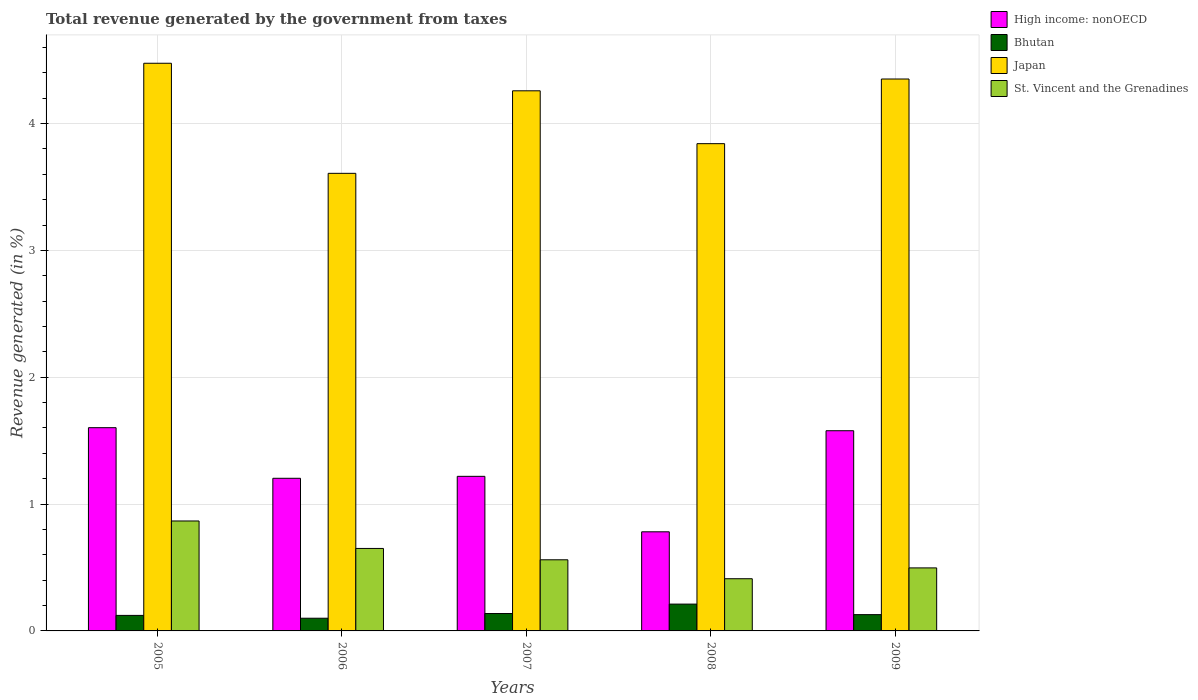How many different coloured bars are there?
Keep it short and to the point. 4. Are the number of bars on each tick of the X-axis equal?
Offer a very short reply. Yes. What is the label of the 3rd group of bars from the left?
Offer a very short reply. 2007. In how many cases, is the number of bars for a given year not equal to the number of legend labels?
Your response must be concise. 0. What is the total revenue generated in High income: nonOECD in 2007?
Ensure brevity in your answer.  1.22. Across all years, what is the maximum total revenue generated in High income: nonOECD?
Make the answer very short. 1.6. Across all years, what is the minimum total revenue generated in St. Vincent and the Grenadines?
Keep it short and to the point. 0.41. In which year was the total revenue generated in St. Vincent and the Grenadines minimum?
Offer a terse response. 2008. What is the total total revenue generated in High income: nonOECD in the graph?
Provide a short and direct response. 6.38. What is the difference between the total revenue generated in Japan in 2005 and that in 2007?
Provide a succinct answer. 0.22. What is the difference between the total revenue generated in Bhutan in 2005 and the total revenue generated in Japan in 2009?
Your answer should be very brief. -4.23. What is the average total revenue generated in St. Vincent and the Grenadines per year?
Provide a succinct answer. 0.6. In the year 2005, what is the difference between the total revenue generated in Japan and total revenue generated in St. Vincent and the Grenadines?
Ensure brevity in your answer.  3.61. What is the ratio of the total revenue generated in St. Vincent and the Grenadines in 2006 to that in 2007?
Make the answer very short. 1.16. Is the total revenue generated in Bhutan in 2007 less than that in 2009?
Make the answer very short. No. Is the difference between the total revenue generated in Japan in 2005 and 2008 greater than the difference between the total revenue generated in St. Vincent and the Grenadines in 2005 and 2008?
Offer a terse response. Yes. What is the difference between the highest and the second highest total revenue generated in Bhutan?
Your answer should be compact. 0.07. What is the difference between the highest and the lowest total revenue generated in High income: nonOECD?
Your response must be concise. 0.82. Is the sum of the total revenue generated in High income: nonOECD in 2005 and 2009 greater than the maximum total revenue generated in Japan across all years?
Keep it short and to the point. No. Is it the case that in every year, the sum of the total revenue generated in Bhutan and total revenue generated in Japan is greater than the sum of total revenue generated in St. Vincent and the Grenadines and total revenue generated in High income: nonOECD?
Provide a succinct answer. Yes. What does the 1st bar from the left in 2007 represents?
Give a very brief answer. High income: nonOECD. What does the 1st bar from the right in 2005 represents?
Your answer should be compact. St. Vincent and the Grenadines. Is it the case that in every year, the sum of the total revenue generated in Japan and total revenue generated in High income: nonOECD is greater than the total revenue generated in St. Vincent and the Grenadines?
Offer a very short reply. Yes. Are all the bars in the graph horizontal?
Your answer should be very brief. No. How many years are there in the graph?
Offer a very short reply. 5. What is the difference between two consecutive major ticks on the Y-axis?
Your answer should be compact. 1. Are the values on the major ticks of Y-axis written in scientific E-notation?
Offer a terse response. No. Does the graph contain any zero values?
Provide a short and direct response. No. Does the graph contain grids?
Your response must be concise. Yes. Where does the legend appear in the graph?
Provide a short and direct response. Top right. How many legend labels are there?
Keep it short and to the point. 4. What is the title of the graph?
Ensure brevity in your answer.  Total revenue generated by the government from taxes. What is the label or title of the Y-axis?
Ensure brevity in your answer.  Revenue generated (in %). What is the Revenue generated (in %) of High income: nonOECD in 2005?
Your answer should be compact. 1.6. What is the Revenue generated (in %) in Bhutan in 2005?
Keep it short and to the point. 0.12. What is the Revenue generated (in %) in Japan in 2005?
Provide a short and direct response. 4.48. What is the Revenue generated (in %) in St. Vincent and the Grenadines in 2005?
Provide a succinct answer. 0.87. What is the Revenue generated (in %) in High income: nonOECD in 2006?
Make the answer very short. 1.2. What is the Revenue generated (in %) of Bhutan in 2006?
Provide a short and direct response. 0.1. What is the Revenue generated (in %) in Japan in 2006?
Offer a terse response. 3.61. What is the Revenue generated (in %) in St. Vincent and the Grenadines in 2006?
Make the answer very short. 0.65. What is the Revenue generated (in %) of High income: nonOECD in 2007?
Ensure brevity in your answer.  1.22. What is the Revenue generated (in %) of Bhutan in 2007?
Provide a short and direct response. 0.14. What is the Revenue generated (in %) in Japan in 2007?
Offer a very short reply. 4.26. What is the Revenue generated (in %) in St. Vincent and the Grenadines in 2007?
Ensure brevity in your answer.  0.56. What is the Revenue generated (in %) in High income: nonOECD in 2008?
Ensure brevity in your answer.  0.78. What is the Revenue generated (in %) in Bhutan in 2008?
Make the answer very short. 0.21. What is the Revenue generated (in %) of Japan in 2008?
Your answer should be very brief. 3.84. What is the Revenue generated (in %) in St. Vincent and the Grenadines in 2008?
Your answer should be very brief. 0.41. What is the Revenue generated (in %) in High income: nonOECD in 2009?
Offer a very short reply. 1.58. What is the Revenue generated (in %) in Bhutan in 2009?
Give a very brief answer. 0.13. What is the Revenue generated (in %) of Japan in 2009?
Offer a terse response. 4.35. What is the Revenue generated (in %) of St. Vincent and the Grenadines in 2009?
Provide a short and direct response. 0.5. Across all years, what is the maximum Revenue generated (in %) in High income: nonOECD?
Ensure brevity in your answer.  1.6. Across all years, what is the maximum Revenue generated (in %) in Bhutan?
Your answer should be compact. 0.21. Across all years, what is the maximum Revenue generated (in %) of Japan?
Your response must be concise. 4.48. Across all years, what is the maximum Revenue generated (in %) of St. Vincent and the Grenadines?
Your answer should be compact. 0.87. Across all years, what is the minimum Revenue generated (in %) in High income: nonOECD?
Make the answer very short. 0.78. Across all years, what is the minimum Revenue generated (in %) of Bhutan?
Provide a short and direct response. 0.1. Across all years, what is the minimum Revenue generated (in %) in Japan?
Ensure brevity in your answer.  3.61. Across all years, what is the minimum Revenue generated (in %) in St. Vincent and the Grenadines?
Your answer should be compact. 0.41. What is the total Revenue generated (in %) in High income: nonOECD in the graph?
Your answer should be compact. 6.38. What is the total Revenue generated (in %) in Bhutan in the graph?
Make the answer very short. 0.7. What is the total Revenue generated (in %) of Japan in the graph?
Provide a short and direct response. 20.53. What is the total Revenue generated (in %) of St. Vincent and the Grenadines in the graph?
Make the answer very short. 2.99. What is the difference between the Revenue generated (in %) in High income: nonOECD in 2005 and that in 2006?
Provide a short and direct response. 0.4. What is the difference between the Revenue generated (in %) of Bhutan in 2005 and that in 2006?
Offer a very short reply. 0.02. What is the difference between the Revenue generated (in %) of Japan in 2005 and that in 2006?
Provide a succinct answer. 0.87. What is the difference between the Revenue generated (in %) of St. Vincent and the Grenadines in 2005 and that in 2006?
Provide a succinct answer. 0.22. What is the difference between the Revenue generated (in %) of High income: nonOECD in 2005 and that in 2007?
Offer a terse response. 0.38. What is the difference between the Revenue generated (in %) in Bhutan in 2005 and that in 2007?
Offer a very short reply. -0.01. What is the difference between the Revenue generated (in %) of Japan in 2005 and that in 2007?
Give a very brief answer. 0.22. What is the difference between the Revenue generated (in %) of St. Vincent and the Grenadines in 2005 and that in 2007?
Your response must be concise. 0.31. What is the difference between the Revenue generated (in %) in High income: nonOECD in 2005 and that in 2008?
Give a very brief answer. 0.82. What is the difference between the Revenue generated (in %) in Bhutan in 2005 and that in 2008?
Keep it short and to the point. -0.09. What is the difference between the Revenue generated (in %) of Japan in 2005 and that in 2008?
Provide a short and direct response. 0.63. What is the difference between the Revenue generated (in %) in St. Vincent and the Grenadines in 2005 and that in 2008?
Your response must be concise. 0.46. What is the difference between the Revenue generated (in %) of High income: nonOECD in 2005 and that in 2009?
Provide a short and direct response. 0.02. What is the difference between the Revenue generated (in %) in Bhutan in 2005 and that in 2009?
Your answer should be compact. -0.01. What is the difference between the Revenue generated (in %) in Japan in 2005 and that in 2009?
Offer a very short reply. 0.12. What is the difference between the Revenue generated (in %) of St. Vincent and the Grenadines in 2005 and that in 2009?
Keep it short and to the point. 0.37. What is the difference between the Revenue generated (in %) in High income: nonOECD in 2006 and that in 2007?
Provide a short and direct response. -0.02. What is the difference between the Revenue generated (in %) of Bhutan in 2006 and that in 2007?
Offer a very short reply. -0.04. What is the difference between the Revenue generated (in %) in Japan in 2006 and that in 2007?
Your answer should be very brief. -0.65. What is the difference between the Revenue generated (in %) in St. Vincent and the Grenadines in 2006 and that in 2007?
Provide a short and direct response. 0.09. What is the difference between the Revenue generated (in %) in High income: nonOECD in 2006 and that in 2008?
Offer a terse response. 0.42. What is the difference between the Revenue generated (in %) of Bhutan in 2006 and that in 2008?
Ensure brevity in your answer.  -0.11. What is the difference between the Revenue generated (in %) in Japan in 2006 and that in 2008?
Give a very brief answer. -0.23. What is the difference between the Revenue generated (in %) of St. Vincent and the Grenadines in 2006 and that in 2008?
Keep it short and to the point. 0.24. What is the difference between the Revenue generated (in %) of High income: nonOECD in 2006 and that in 2009?
Provide a short and direct response. -0.38. What is the difference between the Revenue generated (in %) of Bhutan in 2006 and that in 2009?
Ensure brevity in your answer.  -0.03. What is the difference between the Revenue generated (in %) in Japan in 2006 and that in 2009?
Offer a terse response. -0.74. What is the difference between the Revenue generated (in %) in St. Vincent and the Grenadines in 2006 and that in 2009?
Give a very brief answer. 0.15. What is the difference between the Revenue generated (in %) in High income: nonOECD in 2007 and that in 2008?
Keep it short and to the point. 0.44. What is the difference between the Revenue generated (in %) in Bhutan in 2007 and that in 2008?
Give a very brief answer. -0.07. What is the difference between the Revenue generated (in %) in Japan in 2007 and that in 2008?
Make the answer very short. 0.42. What is the difference between the Revenue generated (in %) in St. Vincent and the Grenadines in 2007 and that in 2008?
Ensure brevity in your answer.  0.15. What is the difference between the Revenue generated (in %) in High income: nonOECD in 2007 and that in 2009?
Make the answer very short. -0.36. What is the difference between the Revenue generated (in %) of Bhutan in 2007 and that in 2009?
Your answer should be very brief. 0.01. What is the difference between the Revenue generated (in %) of Japan in 2007 and that in 2009?
Your response must be concise. -0.09. What is the difference between the Revenue generated (in %) of St. Vincent and the Grenadines in 2007 and that in 2009?
Provide a short and direct response. 0.06. What is the difference between the Revenue generated (in %) in High income: nonOECD in 2008 and that in 2009?
Offer a terse response. -0.8. What is the difference between the Revenue generated (in %) of Bhutan in 2008 and that in 2009?
Give a very brief answer. 0.08. What is the difference between the Revenue generated (in %) in Japan in 2008 and that in 2009?
Ensure brevity in your answer.  -0.51. What is the difference between the Revenue generated (in %) in St. Vincent and the Grenadines in 2008 and that in 2009?
Your answer should be compact. -0.09. What is the difference between the Revenue generated (in %) of High income: nonOECD in 2005 and the Revenue generated (in %) of Bhutan in 2006?
Provide a succinct answer. 1.5. What is the difference between the Revenue generated (in %) of High income: nonOECD in 2005 and the Revenue generated (in %) of Japan in 2006?
Keep it short and to the point. -2.01. What is the difference between the Revenue generated (in %) in High income: nonOECD in 2005 and the Revenue generated (in %) in St. Vincent and the Grenadines in 2006?
Offer a terse response. 0.95. What is the difference between the Revenue generated (in %) of Bhutan in 2005 and the Revenue generated (in %) of Japan in 2006?
Provide a succinct answer. -3.48. What is the difference between the Revenue generated (in %) of Bhutan in 2005 and the Revenue generated (in %) of St. Vincent and the Grenadines in 2006?
Offer a terse response. -0.53. What is the difference between the Revenue generated (in %) in Japan in 2005 and the Revenue generated (in %) in St. Vincent and the Grenadines in 2006?
Your response must be concise. 3.83. What is the difference between the Revenue generated (in %) in High income: nonOECD in 2005 and the Revenue generated (in %) in Bhutan in 2007?
Provide a short and direct response. 1.47. What is the difference between the Revenue generated (in %) of High income: nonOECD in 2005 and the Revenue generated (in %) of Japan in 2007?
Provide a succinct answer. -2.66. What is the difference between the Revenue generated (in %) of High income: nonOECD in 2005 and the Revenue generated (in %) of St. Vincent and the Grenadines in 2007?
Give a very brief answer. 1.04. What is the difference between the Revenue generated (in %) of Bhutan in 2005 and the Revenue generated (in %) of Japan in 2007?
Ensure brevity in your answer.  -4.14. What is the difference between the Revenue generated (in %) in Bhutan in 2005 and the Revenue generated (in %) in St. Vincent and the Grenadines in 2007?
Offer a terse response. -0.44. What is the difference between the Revenue generated (in %) of Japan in 2005 and the Revenue generated (in %) of St. Vincent and the Grenadines in 2007?
Ensure brevity in your answer.  3.91. What is the difference between the Revenue generated (in %) in High income: nonOECD in 2005 and the Revenue generated (in %) in Bhutan in 2008?
Your response must be concise. 1.39. What is the difference between the Revenue generated (in %) in High income: nonOECD in 2005 and the Revenue generated (in %) in Japan in 2008?
Make the answer very short. -2.24. What is the difference between the Revenue generated (in %) of High income: nonOECD in 2005 and the Revenue generated (in %) of St. Vincent and the Grenadines in 2008?
Your response must be concise. 1.19. What is the difference between the Revenue generated (in %) of Bhutan in 2005 and the Revenue generated (in %) of Japan in 2008?
Your answer should be very brief. -3.72. What is the difference between the Revenue generated (in %) in Bhutan in 2005 and the Revenue generated (in %) in St. Vincent and the Grenadines in 2008?
Offer a very short reply. -0.29. What is the difference between the Revenue generated (in %) of Japan in 2005 and the Revenue generated (in %) of St. Vincent and the Grenadines in 2008?
Your response must be concise. 4.06. What is the difference between the Revenue generated (in %) in High income: nonOECD in 2005 and the Revenue generated (in %) in Bhutan in 2009?
Your answer should be compact. 1.47. What is the difference between the Revenue generated (in %) of High income: nonOECD in 2005 and the Revenue generated (in %) of Japan in 2009?
Offer a very short reply. -2.75. What is the difference between the Revenue generated (in %) of High income: nonOECD in 2005 and the Revenue generated (in %) of St. Vincent and the Grenadines in 2009?
Your response must be concise. 1.11. What is the difference between the Revenue generated (in %) in Bhutan in 2005 and the Revenue generated (in %) in Japan in 2009?
Ensure brevity in your answer.  -4.23. What is the difference between the Revenue generated (in %) in Bhutan in 2005 and the Revenue generated (in %) in St. Vincent and the Grenadines in 2009?
Give a very brief answer. -0.37. What is the difference between the Revenue generated (in %) of Japan in 2005 and the Revenue generated (in %) of St. Vincent and the Grenadines in 2009?
Your answer should be very brief. 3.98. What is the difference between the Revenue generated (in %) in High income: nonOECD in 2006 and the Revenue generated (in %) in Bhutan in 2007?
Offer a terse response. 1.07. What is the difference between the Revenue generated (in %) in High income: nonOECD in 2006 and the Revenue generated (in %) in Japan in 2007?
Provide a succinct answer. -3.05. What is the difference between the Revenue generated (in %) of High income: nonOECD in 2006 and the Revenue generated (in %) of St. Vincent and the Grenadines in 2007?
Make the answer very short. 0.64. What is the difference between the Revenue generated (in %) of Bhutan in 2006 and the Revenue generated (in %) of Japan in 2007?
Offer a terse response. -4.16. What is the difference between the Revenue generated (in %) in Bhutan in 2006 and the Revenue generated (in %) in St. Vincent and the Grenadines in 2007?
Your answer should be compact. -0.46. What is the difference between the Revenue generated (in %) of Japan in 2006 and the Revenue generated (in %) of St. Vincent and the Grenadines in 2007?
Give a very brief answer. 3.05. What is the difference between the Revenue generated (in %) of High income: nonOECD in 2006 and the Revenue generated (in %) of Bhutan in 2008?
Keep it short and to the point. 0.99. What is the difference between the Revenue generated (in %) in High income: nonOECD in 2006 and the Revenue generated (in %) in Japan in 2008?
Your response must be concise. -2.64. What is the difference between the Revenue generated (in %) in High income: nonOECD in 2006 and the Revenue generated (in %) in St. Vincent and the Grenadines in 2008?
Offer a terse response. 0.79. What is the difference between the Revenue generated (in %) in Bhutan in 2006 and the Revenue generated (in %) in Japan in 2008?
Keep it short and to the point. -3.74. What is the difference between the Revenue generated (in %) of Bhutan in 2006 and the Revenue generated (in %) of St. Vincent and the Grenadines in 2008?
Provide a short and direct response. -0.31. What is the difference between the Revenue generated (in %) of Japan in 2006 and the Revenue generated (in %) of St. Vincent and the Grenadines in 2008?
Offer a very short reply. 3.2. What is the difference between the Revenue generated (in %) in High income: nonOECD in 2006 and the Revenue generated (in %) in Bhutan in 2009?
Offer a very short reply. 1.07. What is the difference between the Revenue generated (in %) of High income: nonOECD in 2006 and the Revenue generated (in %) of Japan in 2009?
Make the answer very short. -3.15. What is the difference between the Revenue generated (in %) of High income: nonOECD in 2006 and the Revenue generated (in %) of St. Vincent and the Grenadines in 2009?
Your answer should be very brief. 0.71. What is the difference between the Revenue generated (in %) of Bhutan in 2006 and the Revenue generated (in %) of Japan in 2009?
Keep it short and to the point. -4.25. What is the difference between the Revenue generated (in %) of Bhutan in 2006 and the Revenue generated (in %) of St. Vincent and the Grenadines in 2009?
Offer a very short reply. -0.4. What is the difference between the Revenue generated (in %) in Japan in 2006 and the Revenue generated (in %) in St. Vincent and the Grenadines in 2009?
Give a very brief answer. 3.11. What is the difference between the Revenue generated (in %) in High income: nonOECD in 2007 and the Revenue generated (in %) in Bhutan in 2008?
Offer a very short reply. 1.01. What is the difference between the Revenue generated (in %) in High income: nonOECD in 2007 and the Revenue generated (in %) in Japan in 2008?
Your answer should be very brief. -2.62. What is the difference between the Revenue generated (in %) of High income: nonOECD in 2007 and the Revenue generated (in %) of St. Vincent and the Grenadines in 2008?
Make the answer very short. 0.81. What is the difference between the Revenue generated (in %) of Bhutan in 2007 and the Revenue generated (in %) of Japan in 2008?
Make the answer very short. -3.7. What is the difference between the Revenue generated (in %) in Bhutan in 2007 and the Revenue generated (in %) in St. Vincent and the Grenadines in 2008?
Provide a short and direct response. -0.27. What is the difference between the Revenue generated (in %) of Japan in 2007 and the Revenue generated (in %) of St. Vincent and the Grenadines in 2008?
Keep it short and to the point. 3.85. What is the difference between the Revenue generated (in %) of High income: nonOECD in 2007 and the Revenue generated (in %) of Bhutan in 2009?
Your answer should be very brief. 1.09. What is the difference between the Revenue generated (in %) in High income: nonOECD in 2007 and the Revenue generated (in %) in Japan in 2009?
Make the answer very short. -3.13. What is the difference between the Revenue generated (in %) of High income: nonOECD in 2007 and the Revenue generated (in %) of St. Vincent and the Grenadines in 2009?
Give a very brief answer. 0.72. What is the difference between the Revenue generated (in %) in Bhutan in 2007 and the Revenue generated (in %) in Japan in 2009?
Keep it short and to the point. -4.21. What is the difference between the Revenue generated (in %) in Bhutan in 2007 and the Revenue generated (in %) in St. Vincent and the Grenadines in 2009?
Offer a very short reply. -0.36. What is the difference between the Revenue generated (in %) of Japan in 2007 and the Revenue generated (in %) of St. Vincent and the Grenadines in 2009?
Offer a very short reply. 3.76. What is the difference between the Revenue generated (in %) of High income: nonOECD in 2008 and the Revenue generated (in %) of Bhutan in 2009?
Provide a succinct answer. 0.65. What is the difference between the Revenue generated (in %) in High income: nonOECD in 2008 and the Revenue generated (in %) in Japan in 2009?
Provide a succinct answer. -3.57. What is the difference between the Revenue generated (in %) in High income: nonOECD in 2008 and the Revenue generated (in %) in St. Vincent and the Grenadines in 2009?
Your answer should be compact. 0.28. What is the difference between the Revenue generated (in %) of Bhutan in 2008 and the Revenue generated (in %) of Japan in 2009?
Give a very brief answer. -4.14. What is the difference between the Revenue generated (in %) of Bhutan in 2008 and the Revenue generated (in %) of St. Vincent and the Grenadines in 2009?
Give a very brief answer. -0.29. What is the difference between the Revenue generated (in %) of Japan in 2008 and the Revenue generated (in %) of St. Vincent and the Grenadines in 2009?
Your answer should be very brief. 3.34. What is the average Revenue generated (in %) of High income: nonOECD per year?
Provide a succinct answer. 1.28. What is the average Revenue generated (in %) of Bhutan per year?
Offer a very short reply. 0.14. What is the average Revenue generated (in %) in Japan per year?
Your response must be concise. 4.11. What is the average Revenue generated (in %) of St. Vincent and the Grenadines per year?
Ensure brevity in your answer.  0.6. In the year 2005, what is the difference between the Revenue generated (in %) of High income: nonOECD and Revenue generated (in %) of Bhutan?
Your answer should be very brief. 1.48. In the year 2005, what is the difference between the Revenue generated (in %) of High income: nonOECD and Revenue generated (in %) of Japan?
Offer a very short reply. -2.87. In the year 2005, what is the difference between the Revenue generated (in %) in High income: nonOECD and Revenue generated (in %) in St. Vincent and the Grenadines?
Give a very brief answer. 0.74. In the year 2005, what is the difference between the Revenue generated (in %) of Bhutan and Revenue generated (in %) of Japan?
Your response must be concise. -4.35. In the year 2005, what is the difference between the Revenue generated (in %) in Bhutan and Revenue generated (in %) in St. Vincent and the Grenadines?
Keep it short and to the point. -0.74. In the year 2005, what is the difference between the Revenue generated (in %) in Japan and Revenue generated (in %) in St. Vincent and the Grenadines?
Make the answer very short. 3.61. In the year 2006, what is the difference between the Revenue generated (in %) in High income: nonOECD and Revenue generated (in %) in Bhutan?
Your response must be concise. 1.1. In the year 2006, what is the difference between the Revenue generated (in %) in High income: nonOECD and Revenue generated (in %) in Japan?
Keep it short and to the point. -2.4. In the year 2006, what is the difference between the Revenue generated (in %) of High income: nonOECD and Revenue generated (in %) of St. Vincent and the Grenadines?
Give a very brief answer. 0.55. In the year 2006, what is the difference between the Revenue generated (in %) of Bhutan and Revenue generated (in %) of Japan?
Your answer should be very brief. -3.51. In the year 2006, what is the difference between the Revenue generated (in %) of Bhutan and Revenue generated (in %) of St. Vincent and the Grenadines?
Provide a succinct answer. -0.55. In the year 2006, what is the difference between the Revenue generated (in %) in Japan and Revenue generated (in %) in St. Vincent and the Grenadines?
Ensure brevity in your answer.  2.96. In the year 2007, what is the difference between the Revenue generated (in %) of High income: nonOECD and Revenue generated (in %) of Bhutan?
Keep it short and to the point. 1.08. In the year 2007, what is the difference between the Revenue generated (in %) of High income: nonOECD and Revenue generated (in %) of Japan?
Make the answer very short. -3.04. In the year 2007, what is the difference between the Revenue generated (in %) in High income: nonOECD and Revenue generated (in %) in St. Vincent and the Grenadines?
Your response must be concise. 0.66. In the year 2007, what is the difference between the Revenue generated (in %) in Bhutan and Revenue generated (in %) in Japan?
Keep it short and to the point. -4.12. In the year 2007, what is the difference between the Revenue generated (in %) in Bhutan and Revenue generated (in %) in St. Vincent and the Grenadines?
Your answer should be compact. -0.42. In the year 2007, what is the difference between the Revenue generated (in %) in Japan and Revenue generated (in %) in St. Vincent and the Grenadines?
Provide a short and direct response. 3.7. In the year 2008, what is the difference between the Revenue generated (in %) of High income: nonOECD and Revenue generated (in %) of Bhutan?
Offer a very short reply. 0.57. In the year 2008, what is the difference between the Revenue generated (in %) in High income: nonOECD and Revenue generated (in %) in Japan?
Make the answer very short. -3.06. In the year 2008, what is the difference between the Revenue generated (in %) of High income: nonOECD and Revenue generated (in %) of St. Vincent and the Grenadines?
Give a very brief answer. 0.37. In the year 2008, what is the difference between the Revenue generated (in %) in Bhutan and Revenue generated (in %) in Japan?
Keep it short and to the point. -3.63. In the year 2008, what is the difference between the Revenue generated (in %) in Bhutan and Revenue generated (in %) in St. Vincent and the Grenadines?
Give a very brief answer. -0.2. In the year 2008, what is the difference between the Revenue generated (in %) in Japan and Revenue generated (in %) in St. Vincent and the Grenadines?
Your response must be concise. 3.43. In the year 2009, what is the difference between the Revenue generated (in %) of High income: nonOECD and Revenue generated (in %) of Bhutan?
Give a very brief answer. 1.45. In the year 2009, what is the difference between the Revenue generated (in %) of High income: nonOECD and Revenue generated (in %) of Japan?
Give a very brief answer. -2.77. In the year 2009, what is the difference between the Revenue generated (in %) of High income: nonOECD and Revenue generated (in %) of St. Vincent and the Grenadines?
Your answer should be compact. 1.08. In the year 2009, what is the difference between the Revenue generated (in %) in Bhutan and Revenue generated (in %) in Japan?
Give a very brief answer. -4.22. In the year 2009, what is the difference between the Revenue generated (in %) in Bhutan and Revenue generated (in %) in St. Vincent and the Grenadines?
Your answer should be very brief. -0.37. In the year 2009, what is the difference between the Revenue generated (in %) in Japan and Revenue generated (in %) in St. Vincent and the Grenadines?
Offer a very short reply. 3.85. What is the ratio of the Revenue generated (in %) in High income: nonOECD in 2005 to that in 2006?
Provide a succinct answer. 1.33. What is the ratio of the Revenue generated (in %) in Bhutan in 2005 to that in 2006?
Offer a terse response. 1.22. What is the ratio of the Revenue generated (in %) of Japan in 2005 to that in 2006?
Your answer should be compact. 1.24. What is the ratio of the Revenue generated (in %) of St. Vincent and the Grenadines in 2005 to that in 2006?
Ensure brevity in your answer.  1.33. What is the ratio of the Revenue generated (in %) in High income: nonOECD in 2005 to that in 2007?
Keep it short and to the point. 1.31. What is the ratio of the Revenue generated (in %) in Bhutan in 2005 to that in 2007?
Provide a succinct answer. 0.89. What is the ratio of the Revenue generated (in %) of Japan in 2005 to that in 2007?
Offer a terse response. 1.05. What is the ratio of the Revenue generated (in %) in St. Vincent and the Grenadines in 2005 to that in 2007?
Your answer should be compact. 1.55. What is the ratio of the Revenue generated (in %) of High income: nonOECD in 2005 to that in 2008?
Your response must be concise. 2.05. What is the ratio of the Revenue generated (in %) in Bhutan in 2005 to that in 2008?
Ensure brevity in your answer.  0.58. What is the ratio of the Revenue generated (in %) of Japan in 2005 to that in 2008?
Give a very brief answer. 1.17. What is the ratio of the Revenue generated (in %) of St. Vincent and the Grenadines in 2005 to that in 2008?
Your answer should be compact. 2.11. What is the ratio of the Revenue generated (in %) in High income: nonOECD in 2005 to that in 2009?
Offer a terse response. 1.02. What is the ratio of the Revenue generated (in %) of Bhutan in 2005 to that in 2009?
Your answer should be very brief. 0.95. What is the ratio of the Revenue generated (in %) of Japan in 2005 to that in 2009?
Provide a succinct answer. 1.03. What is the ratio of the Revenue generated (in %) of St. Vincent and the Grenadines in 2005 to that in 2009?
Your answer should be compact. 1.74. What is the ratio of the Revenue generated (in %) in High income: nonOECD in 2006 to that in 2007?
Ensure brevity in your answer.  0.99. What is the ratio of the Revenue generated (in %) of Bhutan in 2006 to that in 2007?
Your answer should be compact. 0.73. What is the ratio of the Revenue generated (in %) of Japan in 2006 to that in 2007?
Provide a short and direct response. 0.85. What is the ratio of the Revenue generated (in %) of St. Vincent and the Grenadines in 2006 to that in 2007?
Keep it short and to the point. 1.16. What is the ratio of the Revenue generated (in %) of High income: nonOECD in 2006 to that in 2008?
Give a very brief answer. 1.54. What is the ratio of the Revenue generated (in %) of Bhutan in 2006 to that in 2008?
Your answer should be compact. 0.47. What is the ratio of the Revenue generated (in %) of Japan in 2006 to that in 2008?
Your answer should be very brief. 0.94. What is the ratio of the Revenue generated (in %) in St. Vincent and the Grenadines in 2006 to that in 2008?
Your answer should be very brief. 1.58. What is the ratio of the Revenue generated (in %) in High income: nonOECD in 2006 to that in 2009?
Provide a succinct answer. 0.76. What is the ratio of the Revenue generated (in %) of Bhutan in 2006 to that in 2009?
Offer a terse response. 0.78. What is the ratio of the Revenue generated (in %) of Japan in 2006 to that in 2009?
Provide a succinct answer. 0.83. What is the ratio of the Revenue generated (in %) of St. Vincent and the Grenadines in 2006 to that in 2009?
Your response must be concise. 1.31. What is the ratio of the Revenue generated (in %) in High income: nonOECD in 2007 to that in 2008?
Your answer should be very brief. 1.56. What is the ratio of the Revenue generated (in %) in Bhutan in 2007 to that in 2008?
Your answer should be compact. 0.65. What is the ratio of the Revenue generated (in %) in Japan in 2007 to that in 2008?
Provide a succinct answer. 1.11. What is the ratio of the Revenue generated (in %) of St. Vincent and the Grenadines in 2007 to that in 2008?
Your answer should be compact. 1.36. What is the ratio of the Revenue generated (in %) in High income: nonOECD in 2007 to that in 2009?
Provide a short and direct response. 0.77. What is the ratio of the Revenue generated (in %) in Bhutan in 2007 to that in 2009?
Provide a succinct answer. 1.07. What is the ratio of the Revenue generated (in %) of Japan in 2007 to that in 2009?
Ensure brevity in your answer.  0.98. What is the ratio of the Revenue generated (in %) in St. Vincent and the Grenadines in 2007 to that in 2009?
Provide a short and direct response. 1.13. What is the ratio of the Revenue generated (in %) in High income: nonOECD in 2008 to that in 2009?
Offer a very short reply. 0.5. What is the ratio of the Revenue generated (in %) in Bhutan in 2008 to that in 2009?
Provide a short and direct response. 1.65. What is the ratio of the Revenue generated (in %) in Japan in 2008 to that in 2009?
Make the answer very short. 0.88. What is the ratio of the Revenue generated (in %) in St. Vincent and the Grenadines in 2008 to that in 2009?
Provide a short and direct response. 0.83. What is the difference between the highest and the second highest Revenue generated (in %) of High income: nonOECD?
Offer a very short reply. 0.02. What is the difference between the highest and the second highest Revenue generated (in %) of Bhutan?
Offer a terse response. 0.07. What is the difference between the highest and the second highest Revenue generated (in %) of Japan?
Ensure brevity in your answer.  0.12. What is the difference between the highest and the second highest Revenue generated (in %) of St. Vincent and the Grenadines?
Offer a very short reply. 0.22. What is the difference between the highest and the lowest Revenue generated (in %) of High income: nonOECD?
Keep it short and to the point. 0.82. What is the difference between the highest and the lowest Revenue generated (in %) of Bhutan?
Keep it short and to the point. 0.11. What is the difference between the highest and the lowest Revenue generated (in %) of Japan?
Your response must be concise. 0.87. What is the difference between the highest and the lowest Revenue generated (in %) of St. Vincent and the Grenadines?
Your answer should be compact. 0.46. 